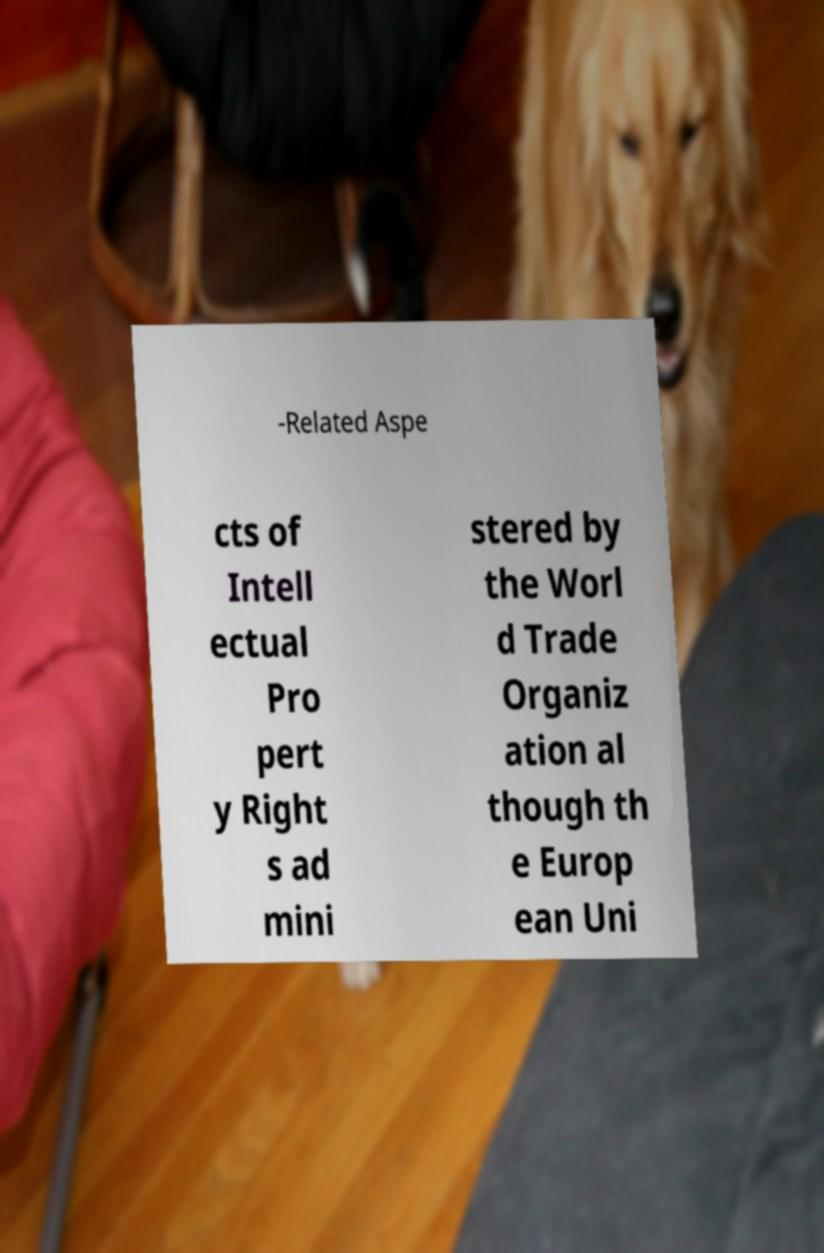What messages or text are displayed in this image? I need them in a readable, typed format. -Related Aspe cts of Intell ectual Pro pert y Right s ad mini stered by the Worl d Trade Organiz ation al though th e Europ ean Uni 